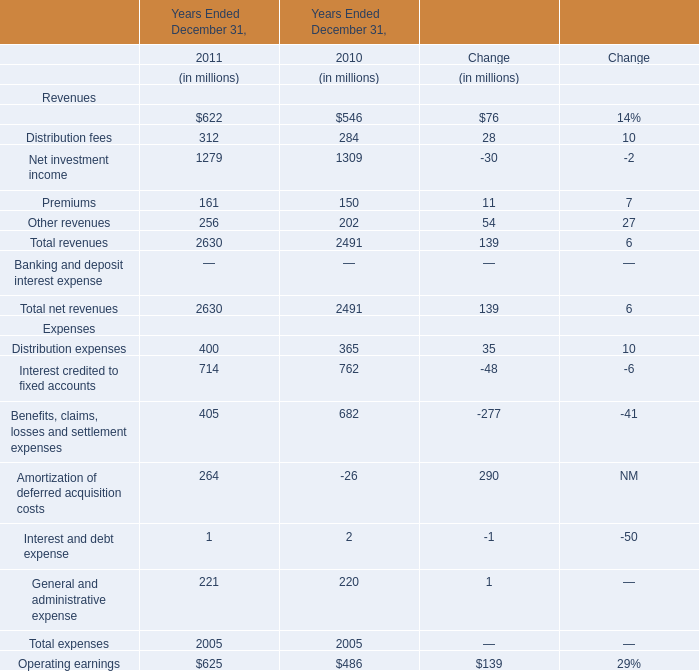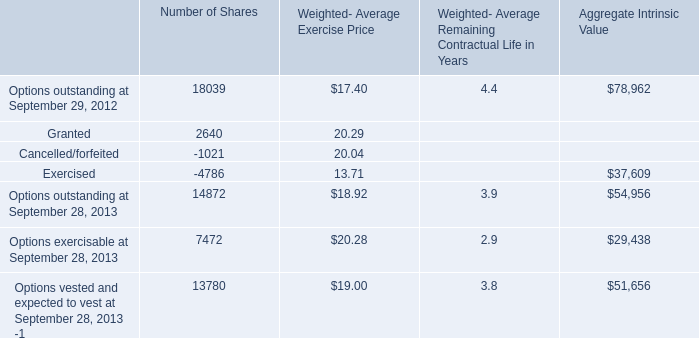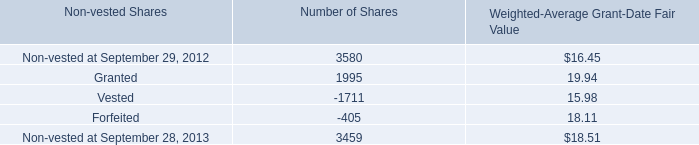What is the sum of the Total expenses in the year where Benefits, claims, losses and settlement expenses is positive? (in million) 
Answer: 2005. 